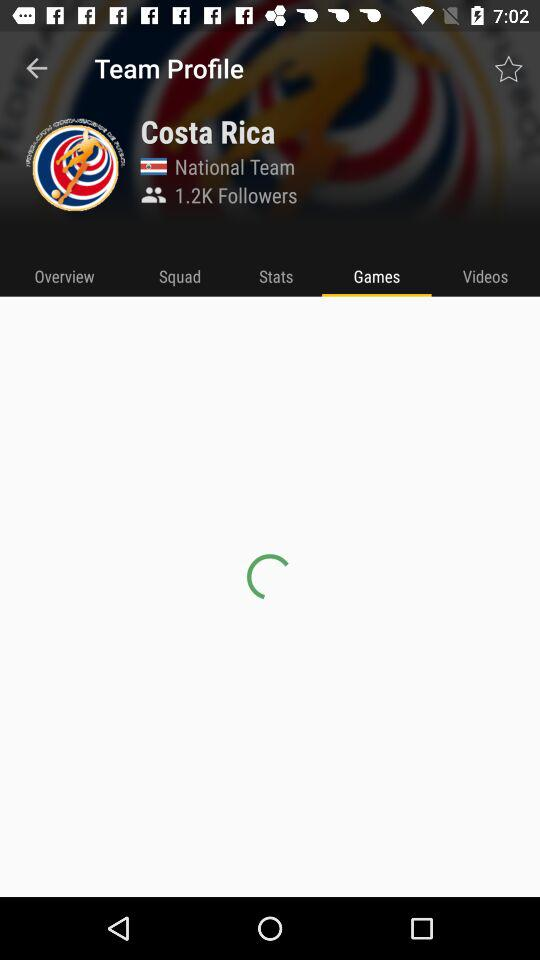What is the name of the team? The name of the team is "Costa Rica". 